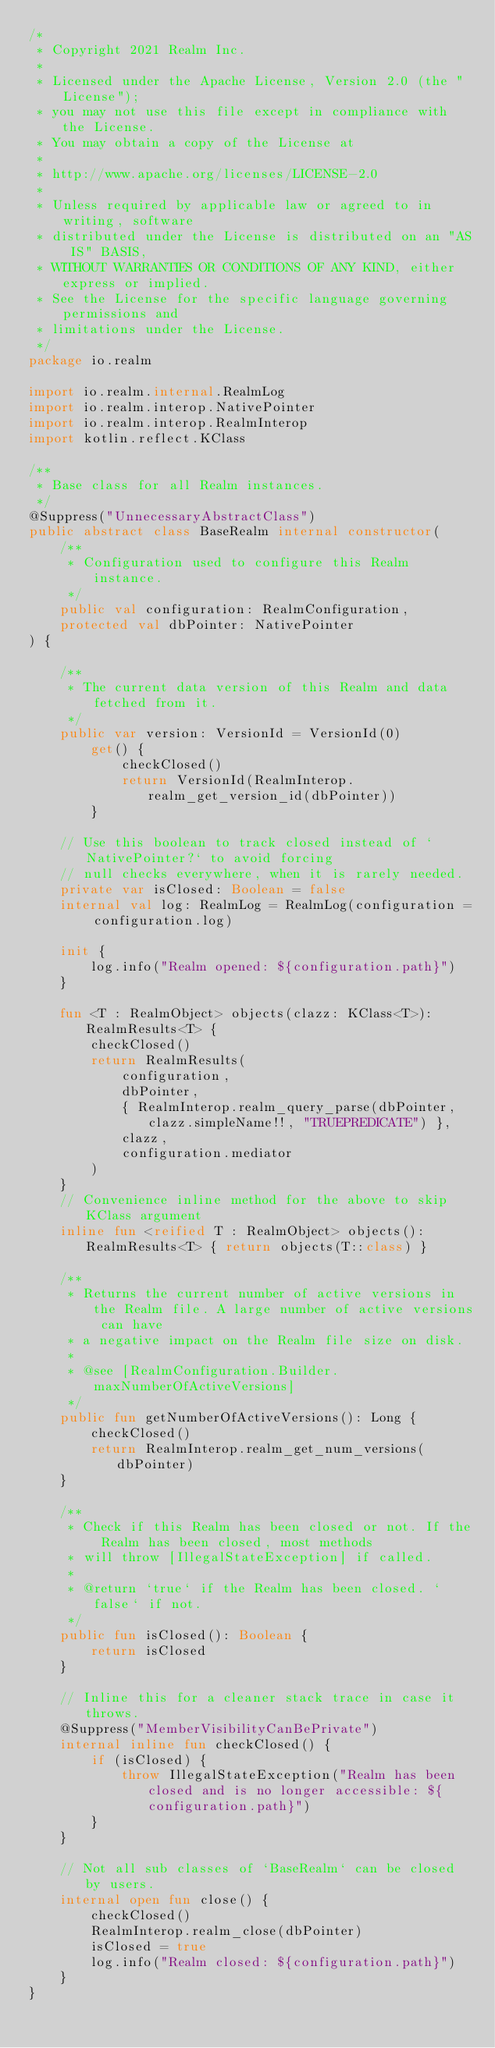<code> <loc_0><loc_0><loc_500><loc_500><_Kotlin_>/*
 * Copyright 2021 Realm Inc.
 *
 * Licensed under the Apache License, Version 2.0 (the "License");
 * you may not use this file except in compliance with the License.
 * You may obtain a copy of the License at
 *
 * http://www.apache.org/licenses/LICENSE-2.0
 *
 * Unless required by applicable law or agreed to in writing, software
 * distributed under the License is distributed on an "AS IS" BASIS,
 * WITHOUT WARRANTIES OR CONDITIONS OF ANY KIND, either express or implied.
 * See the License for the specific language governing permissions and
 * limitations under the License.
 */
package io.realm

import io.realm.internal.RealmLog
import io.realm.interop.NativePointer
import io.realm.interop.RealmInterop
import kotlin.reflect.KClass

/**
 * Base class for all Realm instances.
 */
@Suppress("UnnecessaryAbstractClass")
public abstract class BaseRealm internal constructor(
    /**
     * Configuration used to configure this Realm instance.
     */
    public val configuration: RealmConfiguration,
    protected val dbPointer: NativePointer
) {

    /**
     * The current data version of this Realm and data fetched from it.
     */
    public var version: VersionId = VersionId(0)
        get() {
            checkClosed()
            return VersionId(RealmInterop.realm_get_version_id(dbPointer))
        }

    // Use this boolean to track closed instead of `NativePointer?` to avoid forcing
    // null checks everywhere, when it is rarely needed.
    private var isClosed: Boolean = false
    internal val log: RealmLog = RealmLog(configuration = configuration.log)

    init {
        log.info("Realm opened: ${configuration.path}")
    }

    fun <T : RealmObject> objects(clazz: KClass<T>): RealmResults<T> {
        checkClosed()
        return RealmResults(
            configuration,
            dbPointer,
            { RealmInterop.realm_query_parse(dbPointer, clazz.simpleName!!, "TRUEPREDICATE") },
            clazz,
            configuration.mediator
        )
    }
    // Convenience inline method for the above to skip KClass argument
    inline fun <reified T : RealmObject> objects(): RealmResults<T> { return objects(T::class) }

    /**
     * Returns the current number of active versions in the Realm file. A large number of active versions can have
     * a negative impact on the Realm file size on disk.
     *
     * @see [RealmConfiguration.Builder.maxNumberOfActiveVersions]
     */
    public fun getNumberOfActiveVersions(): Long {
        checkClosed()
        return RealmInterop.realm_get_num_versions(dbPointer)
    }

    /**
     * Check if this Realm has been closed or not. If the Realm has been closed, most methods
     * will throw [IllegalStateException] if called.
     *
     * @return `true` if the Realm has been closed. `false` if not.
     */
    public fun isClosed(): Boolean {
        return isClosed
    }

    // Inline this for a cleaner stack trace in case it throws.
    @Suppress("MemberVisibilityCanBePrivate")
    internal inline fun checkClosed() {
        if (isClosed) {
            throw IllegalStateException("Realm has been closed and is no longer accessible: ${configuration.path}")
        }
    }

    // Not all sub classes of `BaseRealm` can be closed by users.
    internal open fun close() {
        checkClosed()
        RealmInterop.realm_close(dbPointer)
        isClosed = true
        log.info("Realm closed: ${configuration.path}")
    }
}
</code> 